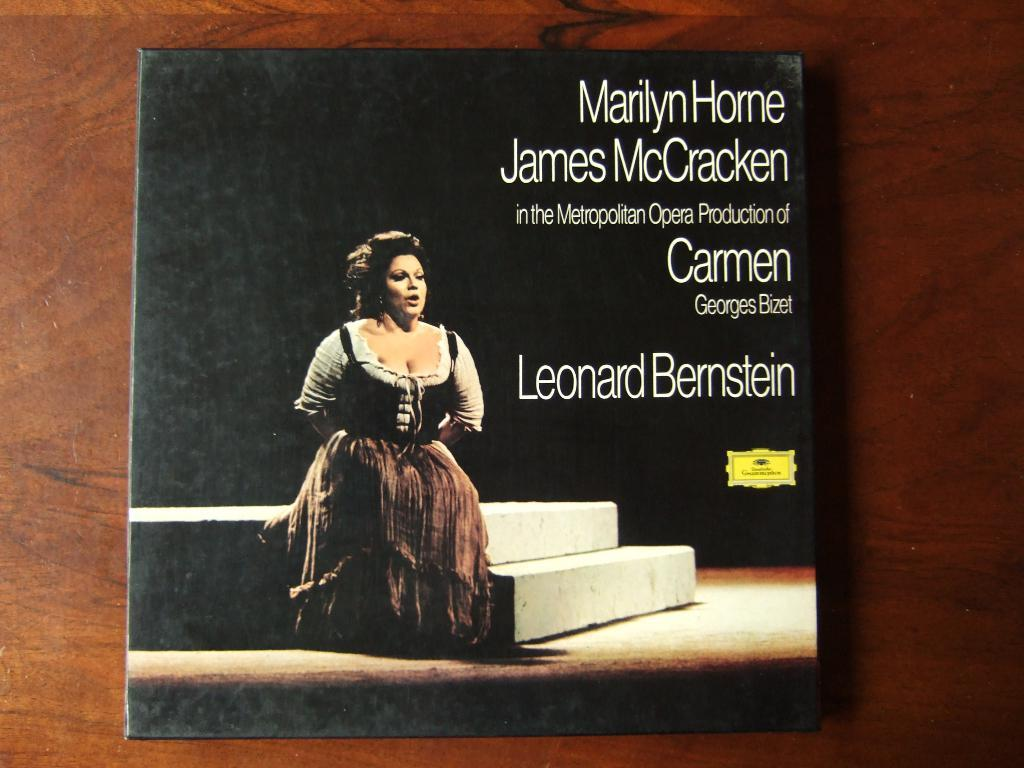Provide a one-sentence caption for the provided image. A record cover for an opera titled Carmen. 